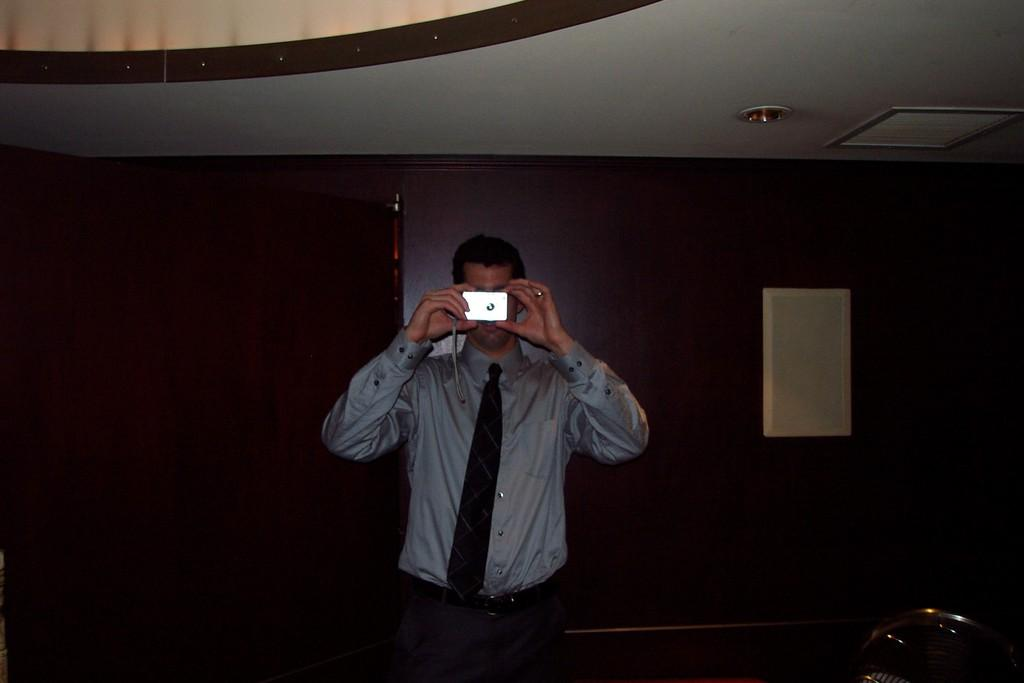Who is present in the image? There is a man in the image. What is the man wearing on his upper body? The man is wearing a grey shirt and a black tie. What is the man holding in his hands? The man is holding a camera in his hands. What can be seen in the background of the image? There is a wall in the background of the image. What type of kettle is the man using to take a bite in the image? There is no kettle or biting action present in the image; the man is holding a camera. 